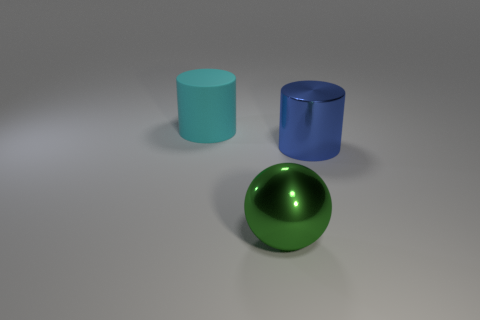Add 1 small green cylinders. How many objects exist? 4 Subtract all balls. How many objects are left? 2 Add 1 big cyan cylinders. How many big cyan cylinders are left? 2 Add 1 metal things. How many metal things exist? 3 Subtract 0 blue blocks. How many objects are left? 3 Subtract all large purple metal balls. Subtract all metal cylinders. How many objects are left? 2 